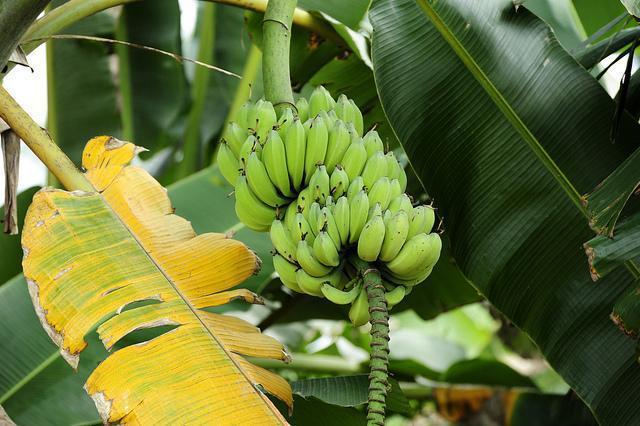How many bananas are there?
Give a very brief answer. 1. How many elephants are there?
Give a very brief answer. 0. 